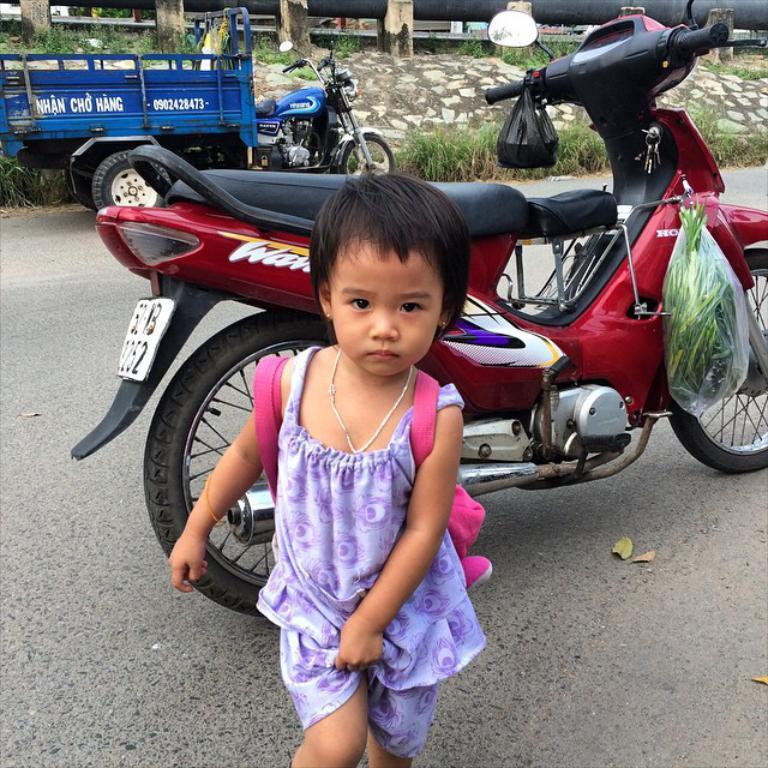How would you summarize this image in a sentence or two? In this picture there is a girl standing. At the back there are vehicles and there are covers on the vehicle. At the back there is a railing and there are plants. At the bottom there is a road and there is reflection of sky and tree on the mirror. 